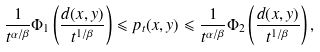<formula> <loc_0><loc_0><loc_500><loc_500>\frac { 1 } { t ^ { \alpha / \beta } } \Phi _ { 1 } \left ( \frac { d ( x , y ) } { t ^ { 1 / \beta } } \right ) \leqslant p _ { t } ( x , y ) \leqslant \frac { 1 } { t ^ { \alpha / \beta } } \Phi _ { 2 } \left ( \frac { d ( x , y ) } { t ^ { 1 / \beta } } \right ) ,</formula> 